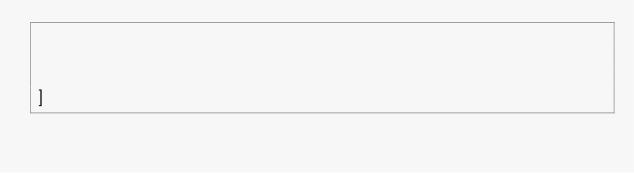<code> <loc_0><loc_0><loc_500><loc_500><_Python_>


]</code> 